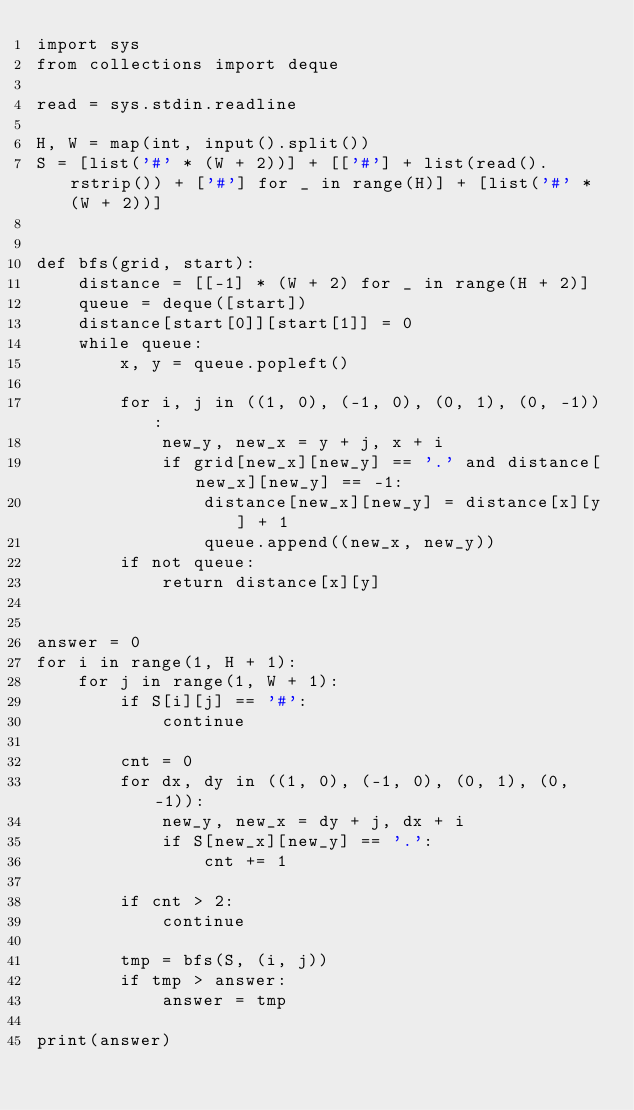Convert code to text. <code><loc_0><loc_0><loc_500><loc_500><_Python_>import sys
from collections import deque

read = sys.stdin.readline

H, W = map(int, input().split())
S = [list('#' * (W + 2))] + [['#'] + list(read().rstrip()) + ['#'] for _ in range(H)] + [list('#' * (W + 2))]


def bfs(grid, start):
    distance = [[-1] * (W + 2) for _ in range(H + 2)]
    queue = deque([start])
    distance[start[0]][start[1]] = 0
    while queue:
        x, y = queue.popleft()

        for i, j in ((1, 0), (-1, 0), (0, 1), (0, -1)):
            new_y, new_x = y + j, x + i
            if grid[new_x][new_y] == '.' and distance[new_x][new_y] == -1:
                distance[new_x][new_y] = distance[x][y] + 1
                queue.append((new_x, new_y))
        if not queue:
            return distance[x][y]


answer = 0
for i in range(1, H + 1):
    for j in range(1, W + 1):
        if S[i][j] == '#':
            continue

        cnt = 0
        for dx, dy in ((1, 0), (-1, 0), (0, 1), (0, -1)):
            new_y, new_x = dy + j, dx + i
            if S[new_x][new_y] == '.':
                cnt += 1

        if cnt > 2:
            continue

        tmp = bfs(S, (i, j))
        if tmp > answer:
            answer = tmp

print(answer)
</code> 